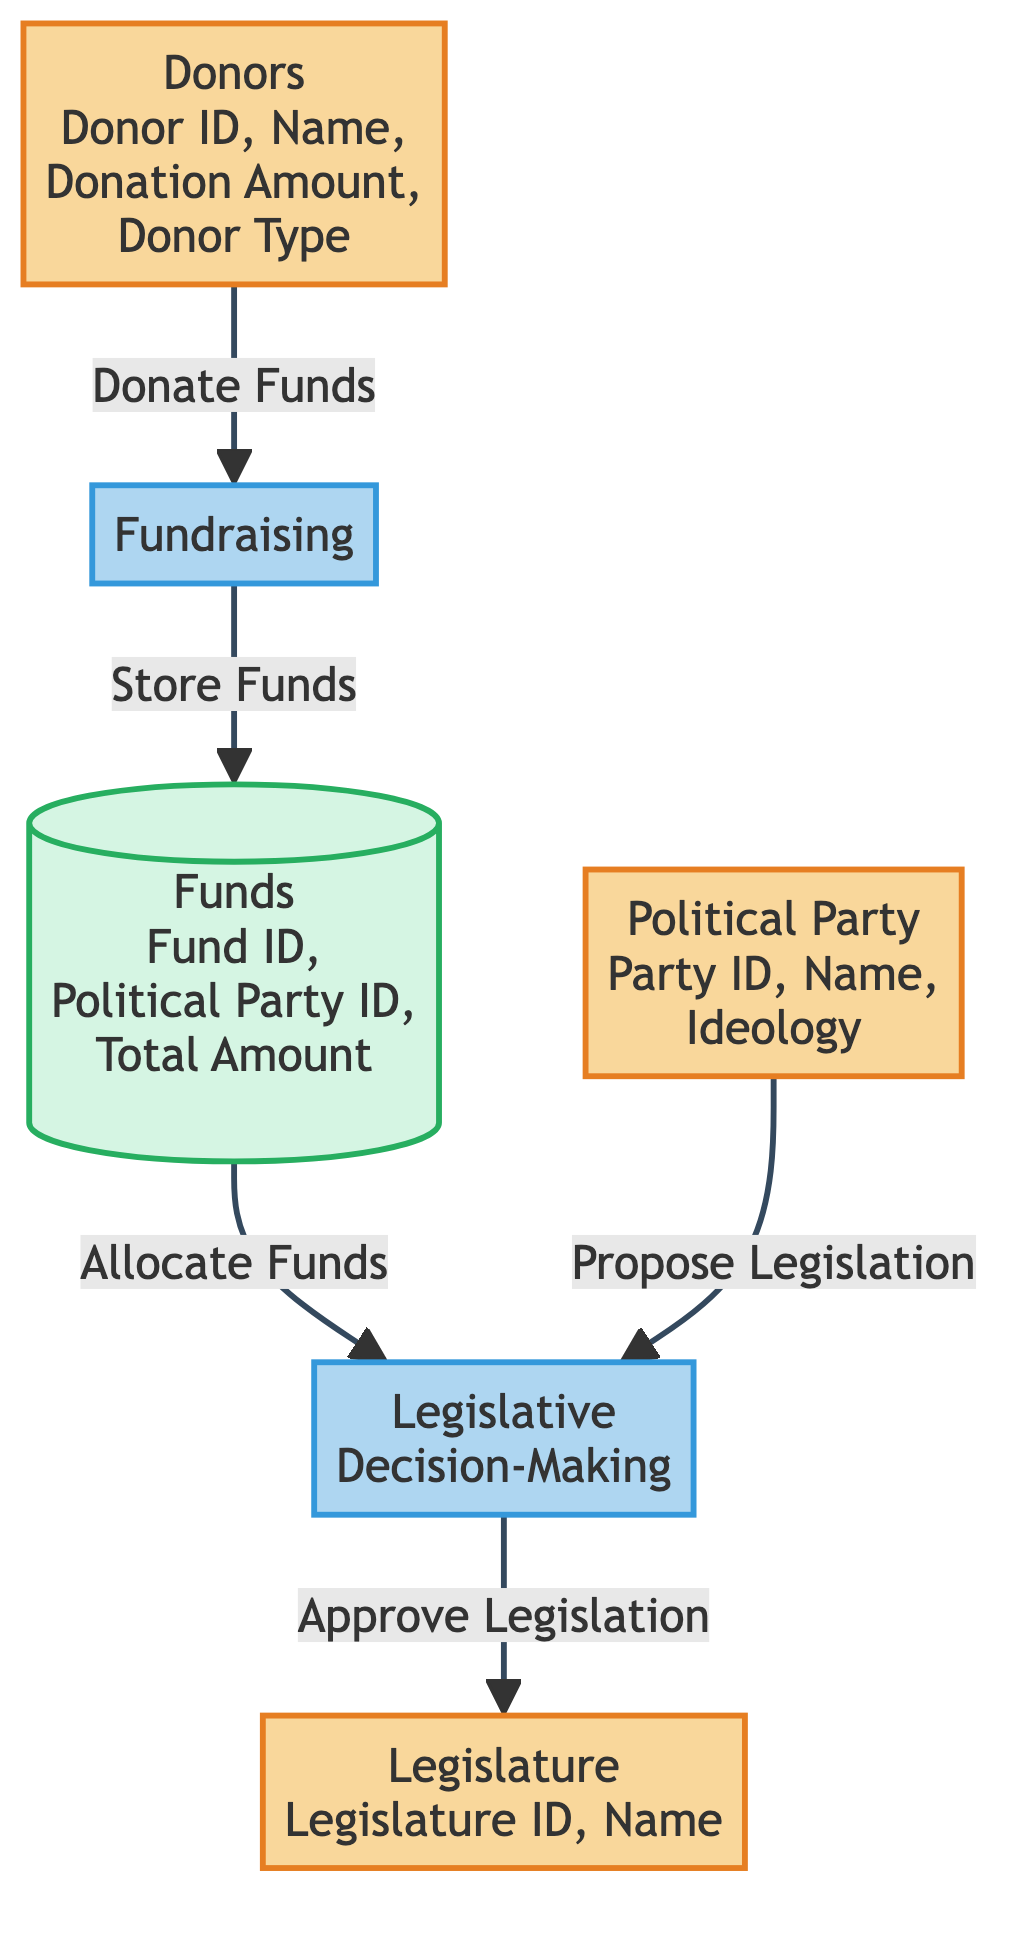What are the inputs to the Fundraising process? The inputs to the Fundraising process are shown as arrows pointing towards it. According to the diagram, the only input is from the Donors entity.
Answer: Donors How many attributes does the Political Party entity have? The attributes of the Political Party entity are listed in the diagram. They are Party ID, Name, and Ideology, which makes a total of three attributes.
Answer: 3 What is the output of the Legislative Decision-Making process? The outputs of the Legislative Decision-Making process are identifiable through the arrows leaving the process. The diagram shows that the output is legislation.
Answer: Legislation Which entities interact with the Funds data store? To determine which entities interact with the Funds data store, I analyze the arrows pointing to and from it. The sources are Fundraising (input) and Legislative Decision-Making (output).
Answer: Fundraising, Legislative Decision-Making Who proposes legislation in the diagram? The diagram indicates the input of the Legislative Decision-Making process comes from the Political Party entity. This means that the Political Party is responsible for proposing legislation.
Answer: Political Party What is the purpose of the Fundraising process? The purpose of the Fundraising process can be determined by examining its inputs and outputs. It takes donations from Donors and produces funds which go into the Funds data store. Therefore, its purpose is to raise funds.
Answer: Raise funds How many entities are present in the diagram? To find the total number of entities, I count all entities listed in the diagram. There are three entities: Donors, Political Party, and Legislature.
Answer: 3 What type of store is Funds categorized as? The diagram classifies Funds with a specific color and stroke type designated for data stores. It shows that Funds is categorized as a data store.
Answer: Data store What is the flow direction from Donations to Funds? The direction of flow is indicated by arrows in the diagram. Donations move towards the Fundraising process, which then leads to the Funds data store, clearly indicating the flow direction is from Donations to Fundraising to Funds.
Answer: Donate Funds 